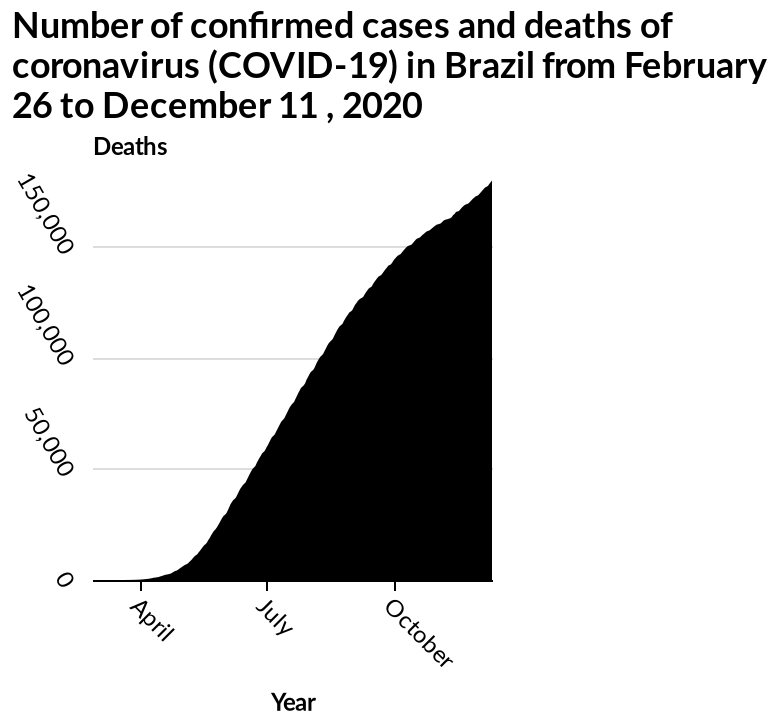<image>
What is the data being plotted on the y-axis of the area graph?  The y-axis of the area graph represents the number of deaths due to coronavirus (COVID-19) in Brazil. please describe the details of the chart Number of confirmed cases and deaths of coronavirus (COVID-19) in Brazil from February 26 to December 11 , 2020 is a area graph. Year is plotted on a categorical scale starting with April and ending with October along the x-axis. Deaths is plotted along the y-axis. 